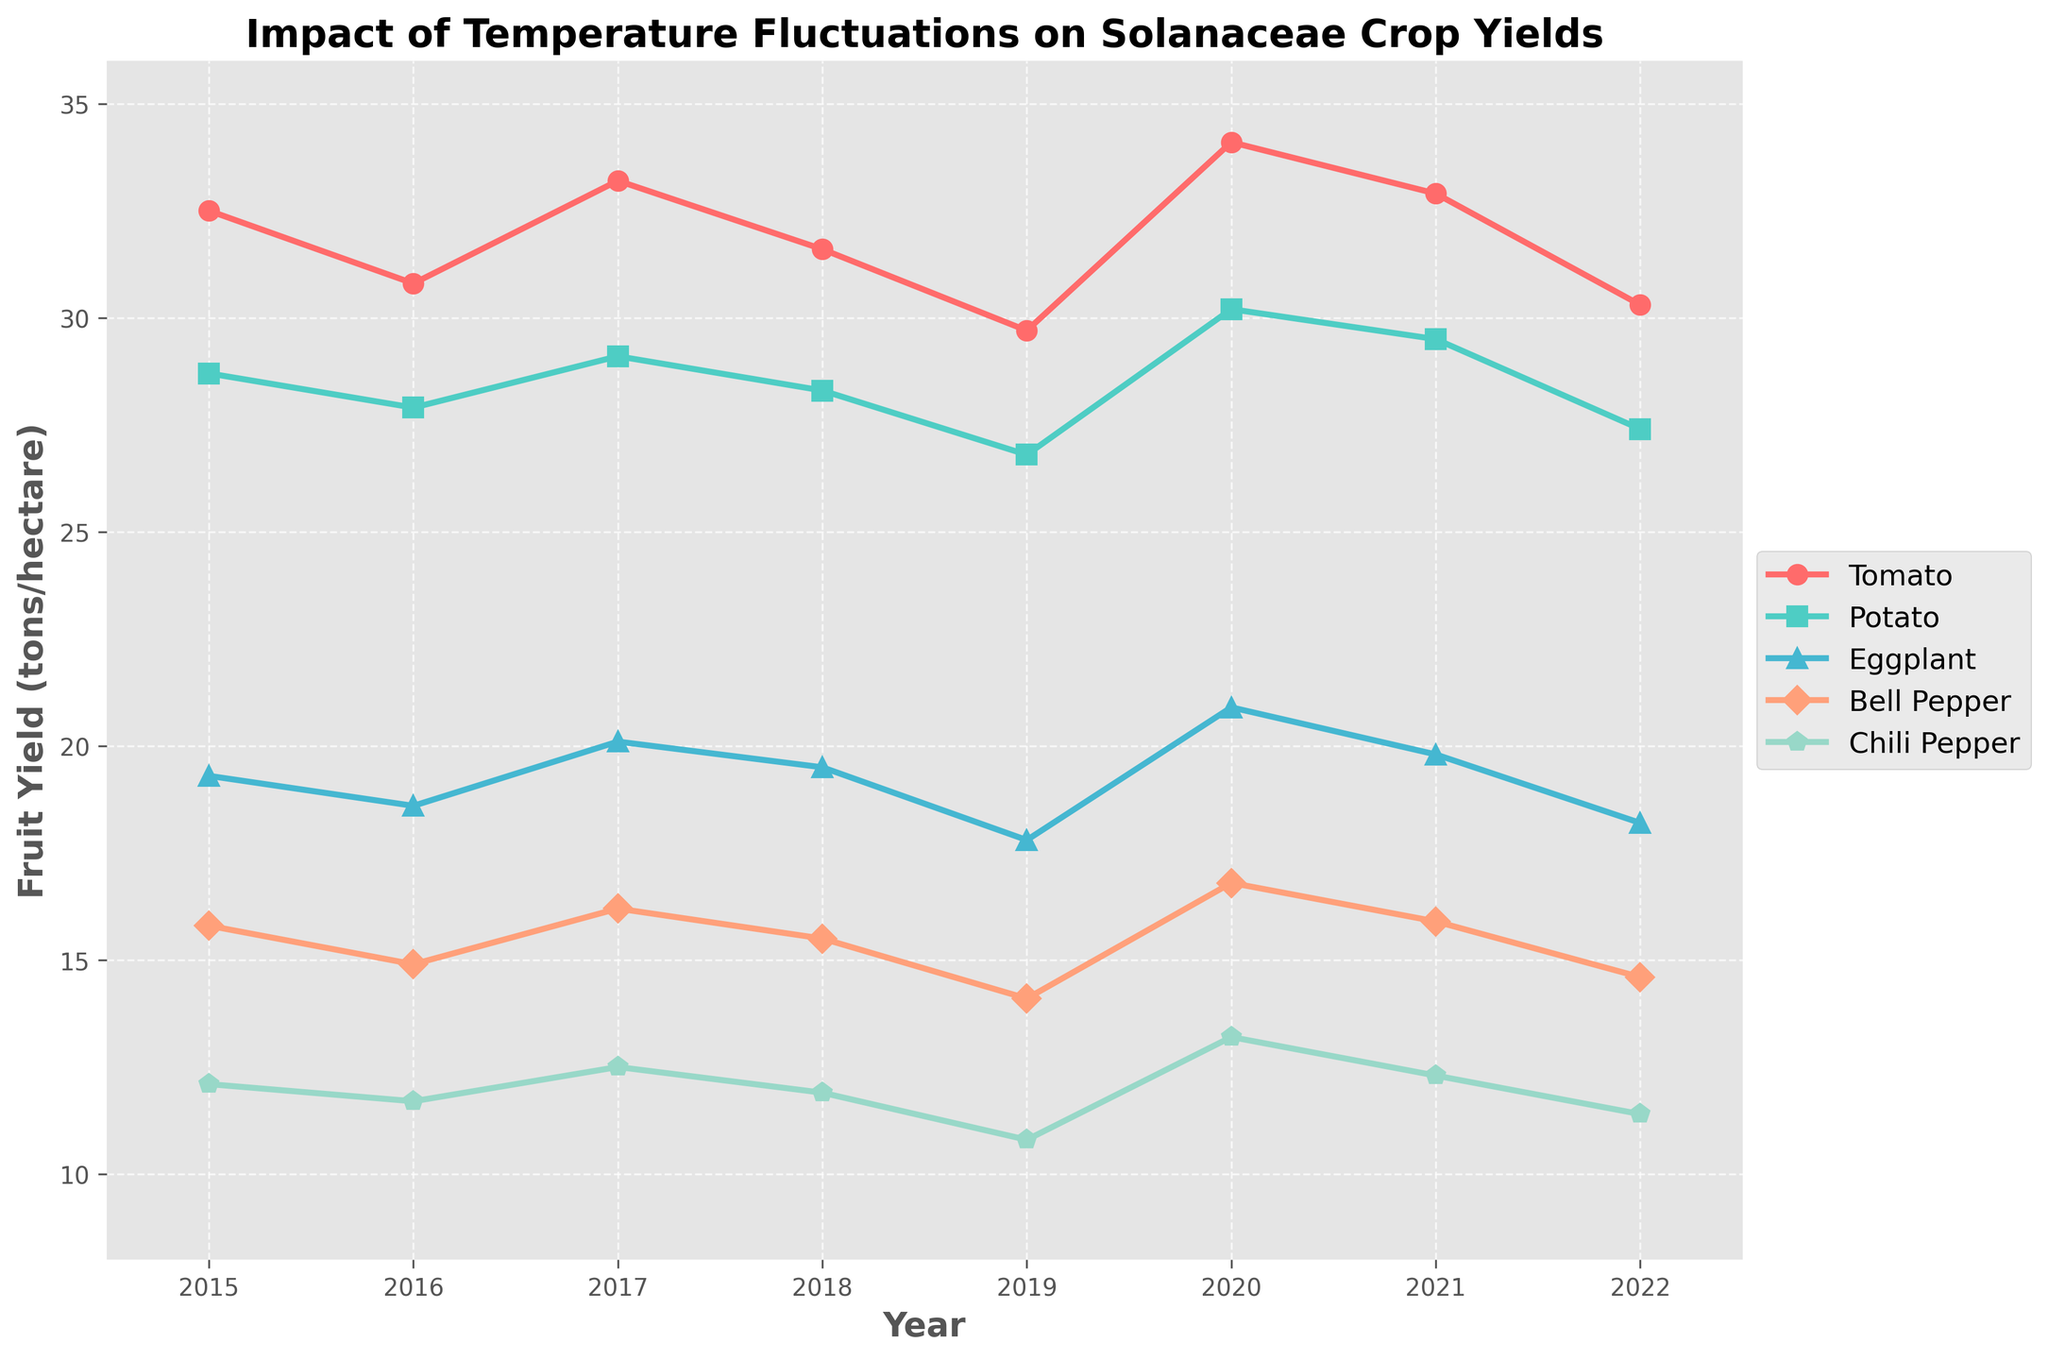what is the trend of tomato yield from 2015 to 2022? To determine the trend, observe the line representing tomato yield over the years. It starts at a value of 32.5 in 2015, fluctuates over the next years, and ends at 30.3 in 2022. The overall trend indicates a slight decrease.
Answer: Slight decrease Which crop had the highest yield in 2020? Look at the data points for the year 2020 across all five crops. The highest value is for Tomato at 34.1.
Answer: Tomato In which year was the Potato yield the lowest? Check the line representing Potato yield and identify the smallest value. The lowest yield for Potato is in 2019 with a value of 26.8.
Answer: 2019 Is there any year where all the yields for Eggplant, Bell Pepper, and Chili Pepper increased from the previous year? Compare the yield values for Eggplant, Bell Pepper, and Chili Pepper for each consecutive year. In 2020, all three crops (Eggplant: 20.9, Bell Pepper: 16.8, Chili Pepper: 13.2) increased from their 2019 values (Eggplant: 17.8, Bell Pepper: 14.1, Chili Pepper: 10.8).
Answer: 2020 What is the average yield of Bell Pepper from 2015 to 2022? Add up the Bell Pepper yields over the years and then divide by the number of years: (15.8 + 14.9 + 16.2 + 15.5 + 14.1 + 16.8 + 15.9 + 14.6) / 8 = 15.5.
Answer: 15.5 Between Tomato and Chili Pepper, which crop showed more variability in their yield from 2015 to 2022? Calculate the range for each crop. Tomato ranges from 29.7 to 34.1, a range of 4.4. Chili Pepper ranges from 10.8 to 13.2, a range of 2.4. Tomato shows more variability.
Answer: Tomato How did the Eggplant yield in 2019 compare to its yield in 2015? Compare the Eggplant yield in 2019 (17.8) to its yield in 2015 (19.3). The 2019 yield is lower.
Answer: Lower What is the total yield for Potatoes from 2016 to 2018? Add the Potato yields for the years 2016, 2017, and 2018: 27.9 + 29.1 + 28.3 = 85.3.
Answer: 85.3 Which crop had the least yield variation across all the years? Calculate the range (difference between the highest and lowest yield) for each crop and compare. The crop with the smallest range is Chili Pepper, with a range from 10.8 to 13.2, a difference of 2.4.
Answer: Chili Pepper How does the yield of Chili Pepper in 2022 compare to its yield in 2015? Compare the yield of Chili Pepper in 2022 (11.4) to its yield in 2015 (12.1). The 2022 yield is lower.
Answer: Lower 